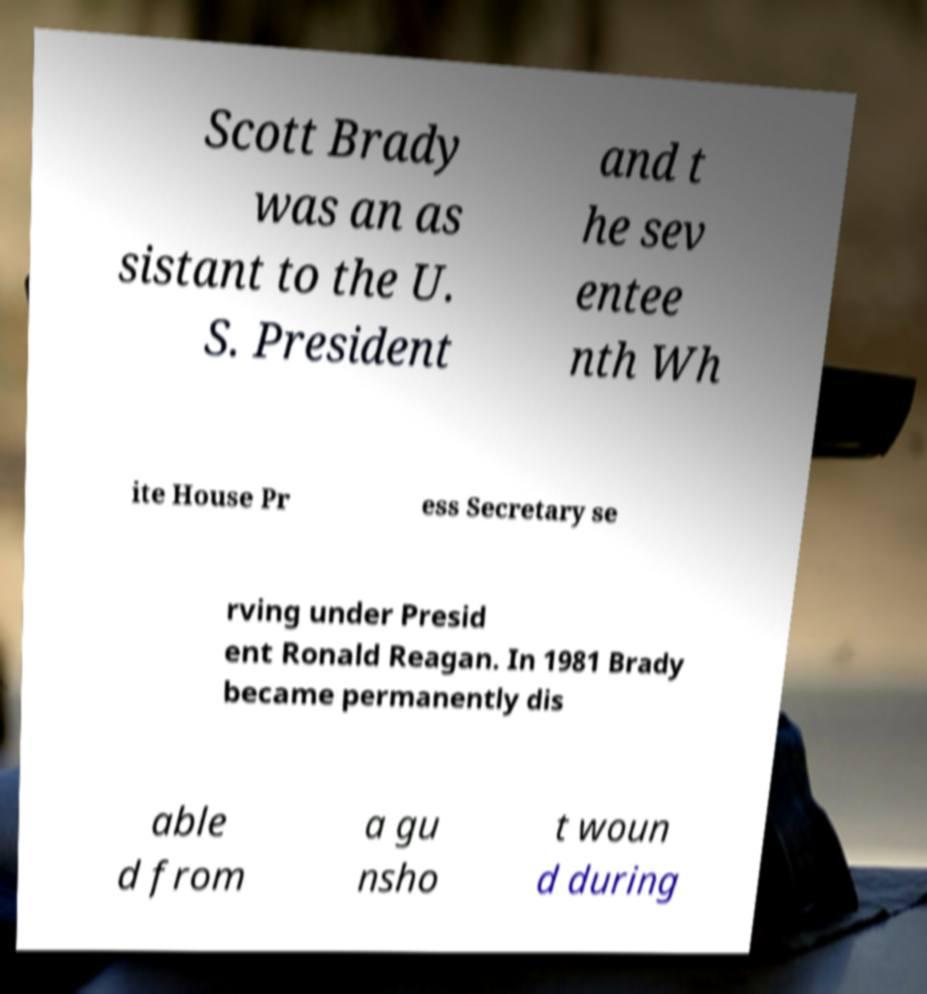Please read and relay the text visible in this image. What does it say? Scott Brady was an as sistant to the U. S. President and t he sev entee nth Wh ite House Pr ess Secretary se rving under Presid ent Ronald Reagan. In 1981 Brady became permanently dis able d from a gu nsho t woun d during 